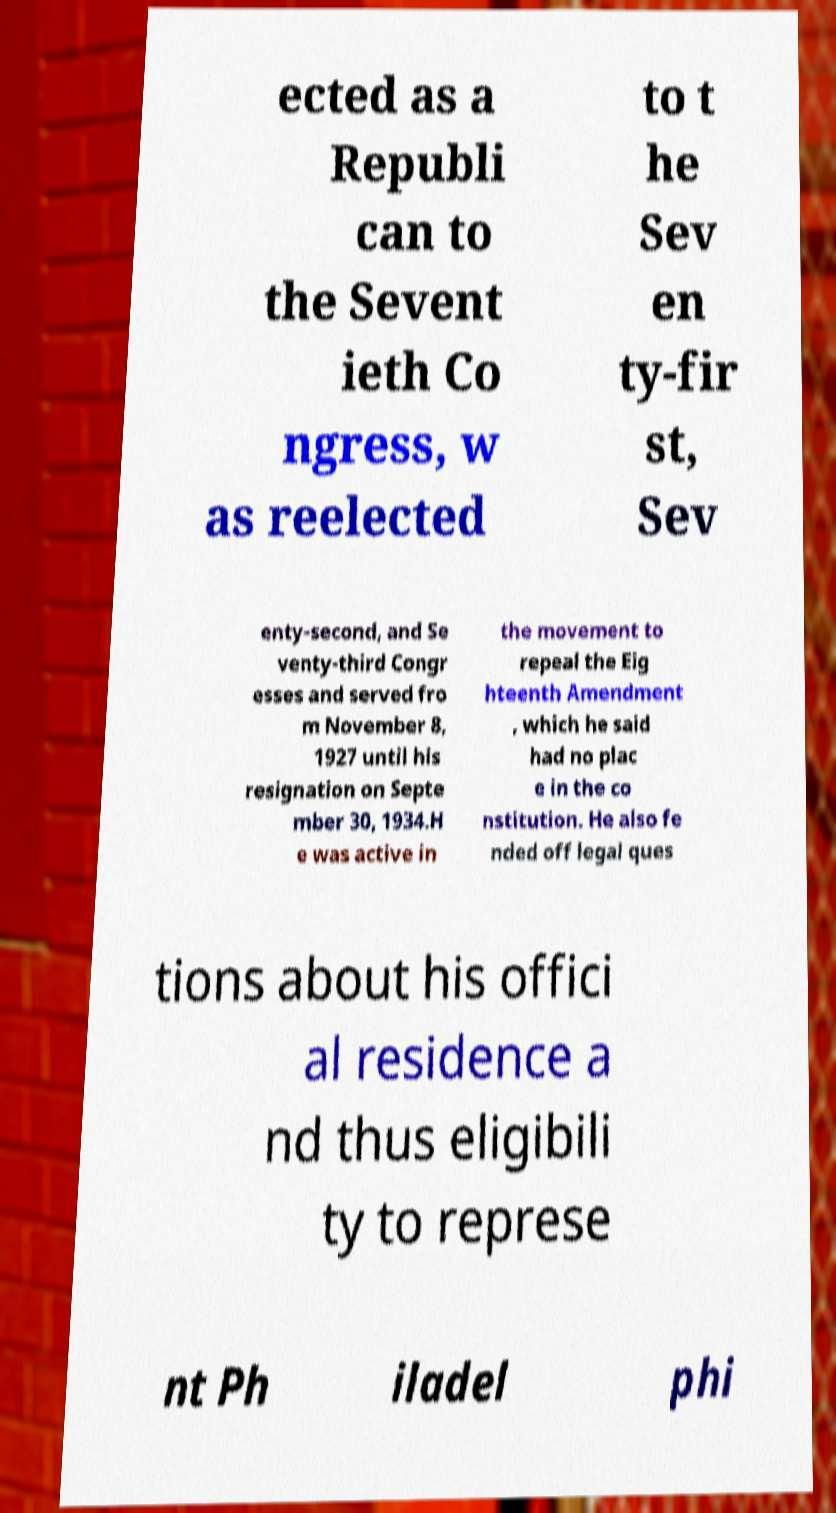Could you extract and type out the text from this image? ected as a Republi can to the Sevent ieth Co ngress, w as reelected to t he Sev en ty-fir st, Sev enty-second, and Se venty-third Congr esses and served fro m November 8, 1927 until his resignation on Septe mber 30, 1934.H e was active in the movement to repeal the Eig hteenth Amendment , which he said had no plac e in the co nstitution. He also fe nded off legal ques tions about his offici al residence a nd thus eligibili ty to represe nt Ph iladel phi 